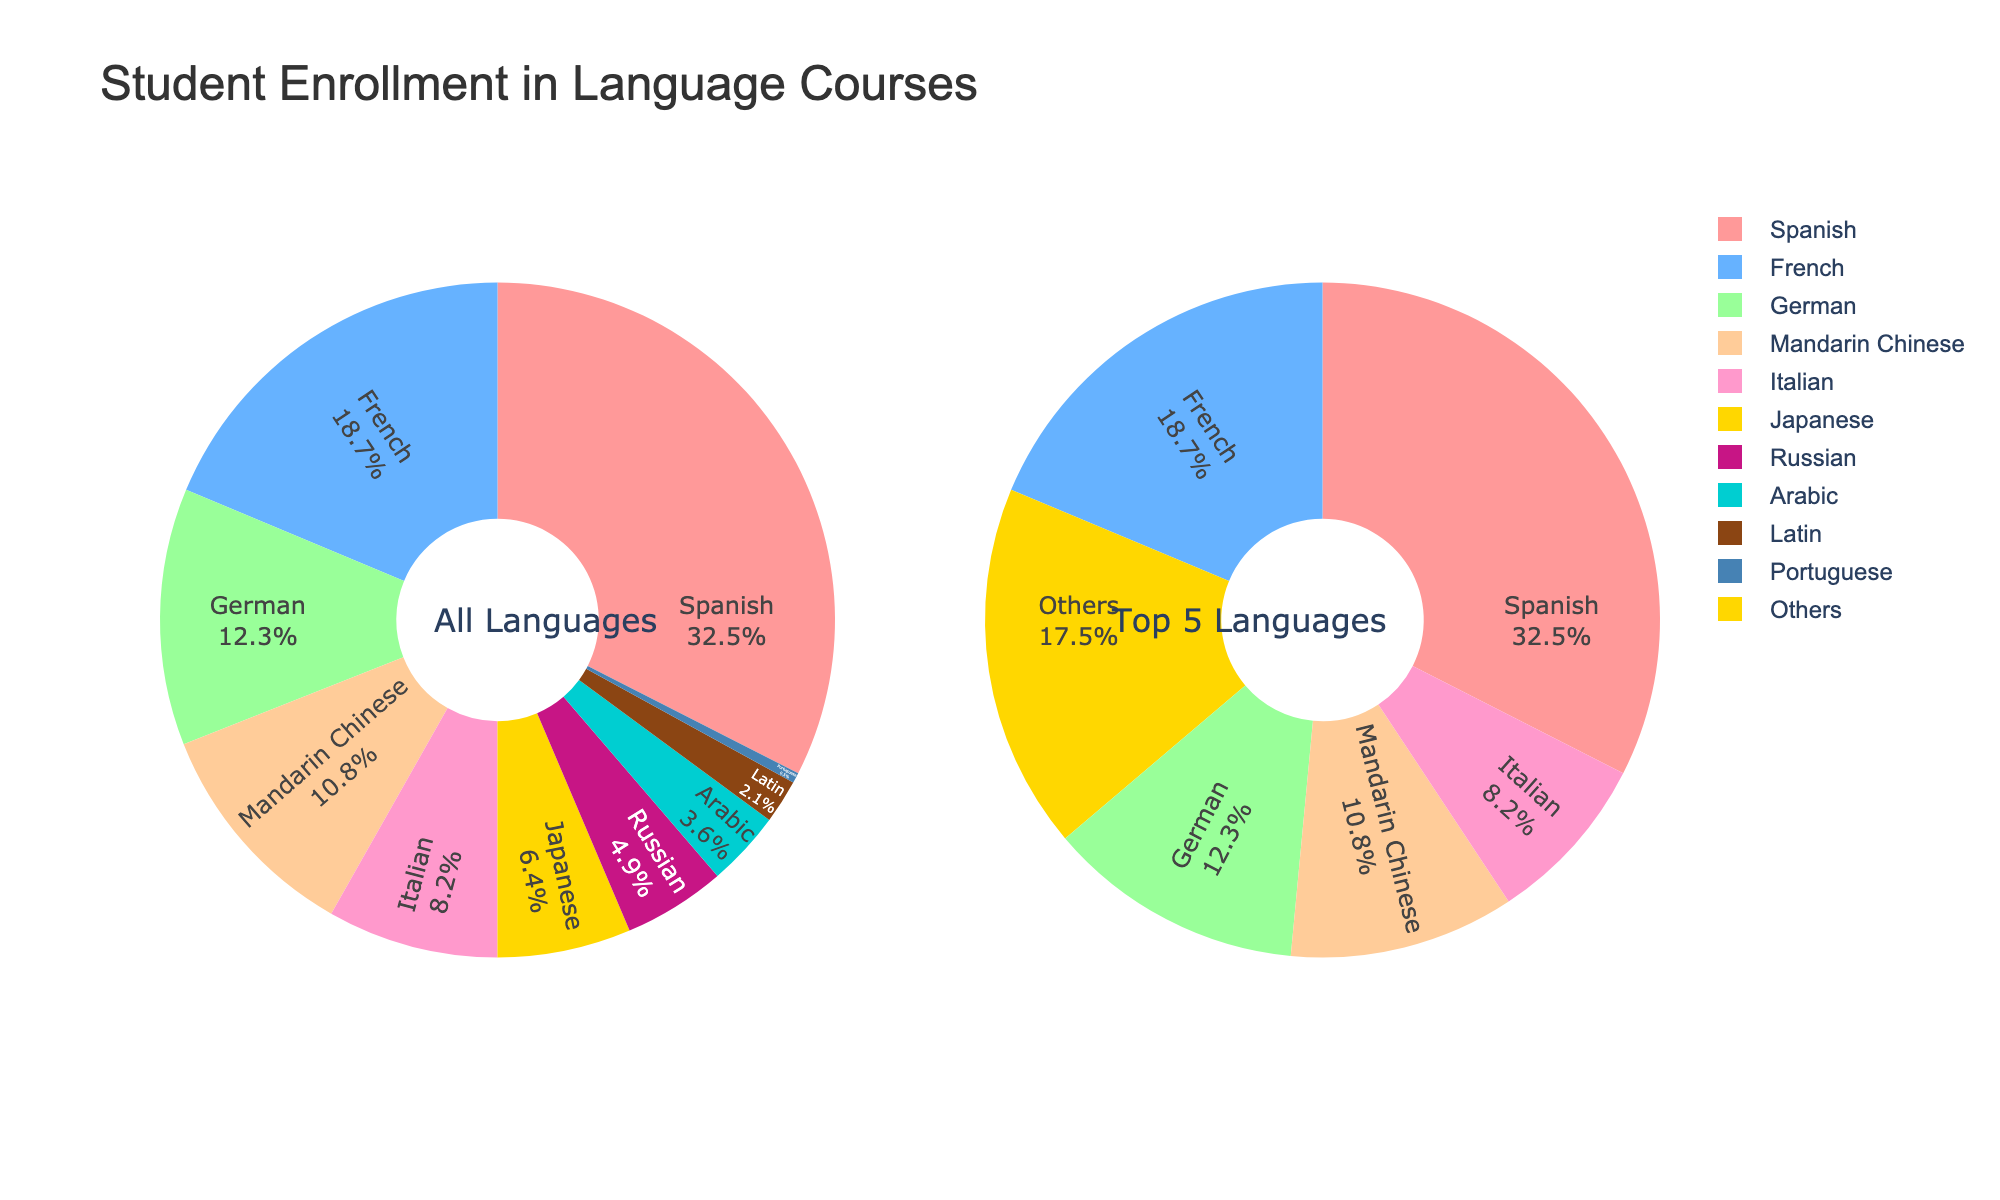What is the enrollment percentage for Spanish? Locate the wedge that represents Spanish in the pie chart for “All Languages”. The label indicates 32.5%, which is the enrollment percentage for Spanish.
Answer: 32.5% Which language courses account for less than 5% of student enrollment? Refer to the pie chart for “All Languages” and identify the labels with enrollment percentages less than 5%. These include Russian (4.9%), Arabic (3.6%), Latin (2.1%), and Portuguese (0.5%).
Answer: Russian, Arabic, Latin, Portuguese What is the combined enrollment percentage for French, German, and Mandarin Chinese? Locate the percentages for French (18.7%), German (12.3%), and Mandarin Chinese (10.8%) in the pie chart for “All Languages”. Sum these values: 18.7% + 12.3% + 10.8% = 41.8%.
Answer: 41.8% Which language has the smallest proportional enrollment? Identify the wedge with the smallest size in the pie chart for “All Languages”. The smallest wedge represents Portuguese with 0.5%.
Answer: Portuguese How does Arabic compare to Latin in terms of enrollment percentage? Highlight the wedges for Arabic (3.6%) and Latin (2.1%) in the pie chart for “All Languages”. Arabic has a higher enrollment percentage compared to Latin.
Answer: Arabic has a higher enrollment What is the difference in enrollment percentage between Italian and Japanese? Observe and note the percentages for Italian (8.2%) and Japanese (6.4%) in the pie chart for “All Languages”. Compute the difference: 8.2% - 6.4% = 1.8%.
Answer: 1.8% Is the proportion of students enrolled in German greater than the combined enrollment of Russian and Latin? Identify the enrollment percentages for German (12.3%), Russian (4.9%), and Latin (2.1%) in the pie chart for “All Languages”. Sum Russian and Latin percentages: 4.9% + 2.1% = 7%. German (12.3%) is greater than 7%.
Answer: Yes What is the enrollment percentage for languages categorized as "Others" in the pie chart for "Top 5 Languages"? Look for the “Others” section in the pie chart for “Top 5 Languages” and read its label, which indicates that “Others” account for 17.8%.
Answer: 17.8% What are the top 5 languages in terms of student enrollment? Refer to the pie chart for “Top 5 Languages” and identify the labels. The top 5 languages are Spanish, French, German, Mandarin Chinese, and Italian.
Answer: Spanish, French, German, Mandarin Chinese, Italian 